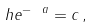<formula> <loc_0><loc_0><loc_500><loc_500>h e ^ { - \ a } = c \, ,</formula> 